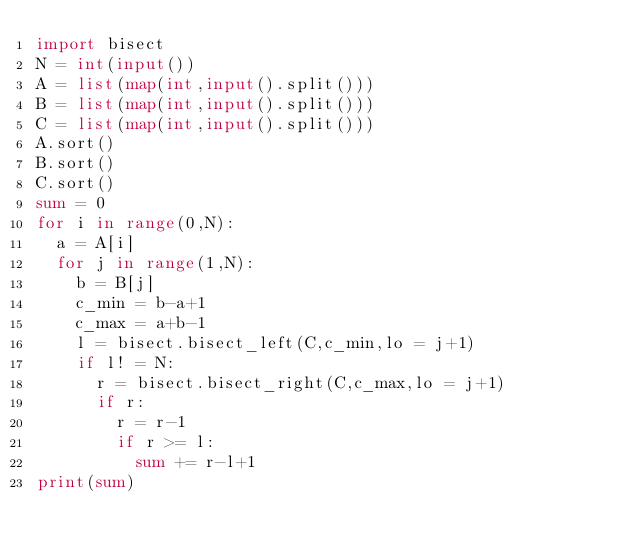Convert code to text. <code><loc_0><loc_0><loc_500><loc_500><_Python_>import bisect
N = int(input())
A = list(map(int,input().split()))
B = list(map(int,input().split()))
C = list(map(int,input().split()))
A.sort()
B.sort()
C.sort()
sum = 0
for i in range(0,N):
  a = A[i]
  for j in range(1,N):
    b = B[j]
    c_min = b-a+1
    c_max = a+b-1
    l = bisect.bisect_left(C,c_min,lo = j+1)
    if l! = N:
      r = bisect.bisect_right(C,c_max,lo = j+1)
      if r:
        r = r-1
        if r >= l:
          sum += r-l+1
print(sum)</code> 